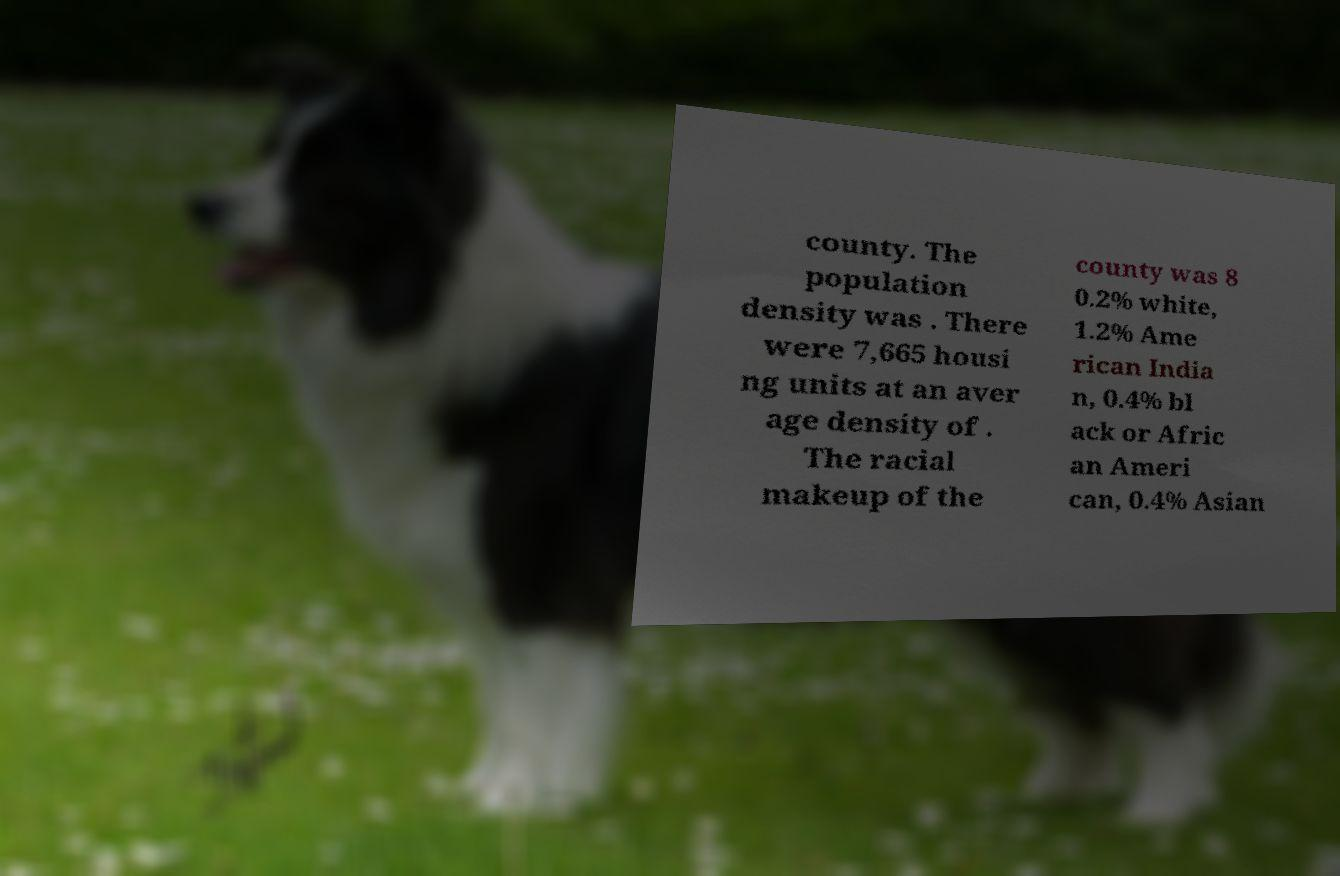Can you read and provide the text displayed in the image?This photo seems to have some interesting text. Can you extract and type it out for me? county. The population density was . There were 7,665 housi ng units at an aver age density of . The racial makeup of the county was 8 0.2% white, 1.2% Ame rican India n, 0.4% bl ack or Afric an Ameri can, 0.4% Asian 